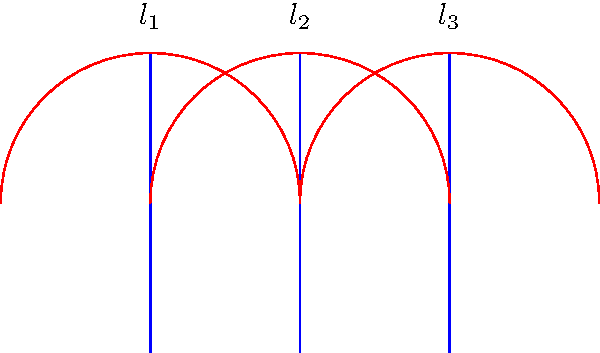In a hyperbolic plane, three lines $l_1$, $l_2$, and $l_3$ are drawn as shown. Initially, they appear parallel. However, as we extend these lines indefinitely, what happens to their relationship due to the curvature of the hyperbolic plane? To understand this, let's follow these steps:

1. In Euclidean geometry, parallel lines remain equidistant and never intersect.

2. However, in hyperbolic geometry, the concept of parallelism is different due to the negative curvature of the space.

3. The red arcs in the diagram represent the curvature of the hyperbolic plane.

4. As we extend the lines $l_1$, $l_2$, and $l_3$ following the curvature:
   a) They will start to diverge from each other.
   b) The distance between them will increase as they extend further.

5. This divergence occurs because:
   a) In hyperbolic geometry, the sum of angles in a triangle is less than 180°.
   b) This property causes parallel lines to behave differently than in Euclidean geometry.

6. The lines will never intersect, but they will grow increasingly apart.

7. This phenomenon is known as "ultraparallel" or "divergently parallel" in hyperbolic geometry.

Therefore, despite initially appearing parallel, the lines will diverge as they extend indefinitely in the hyperbolic plane.
Answer: The lines diverge. 